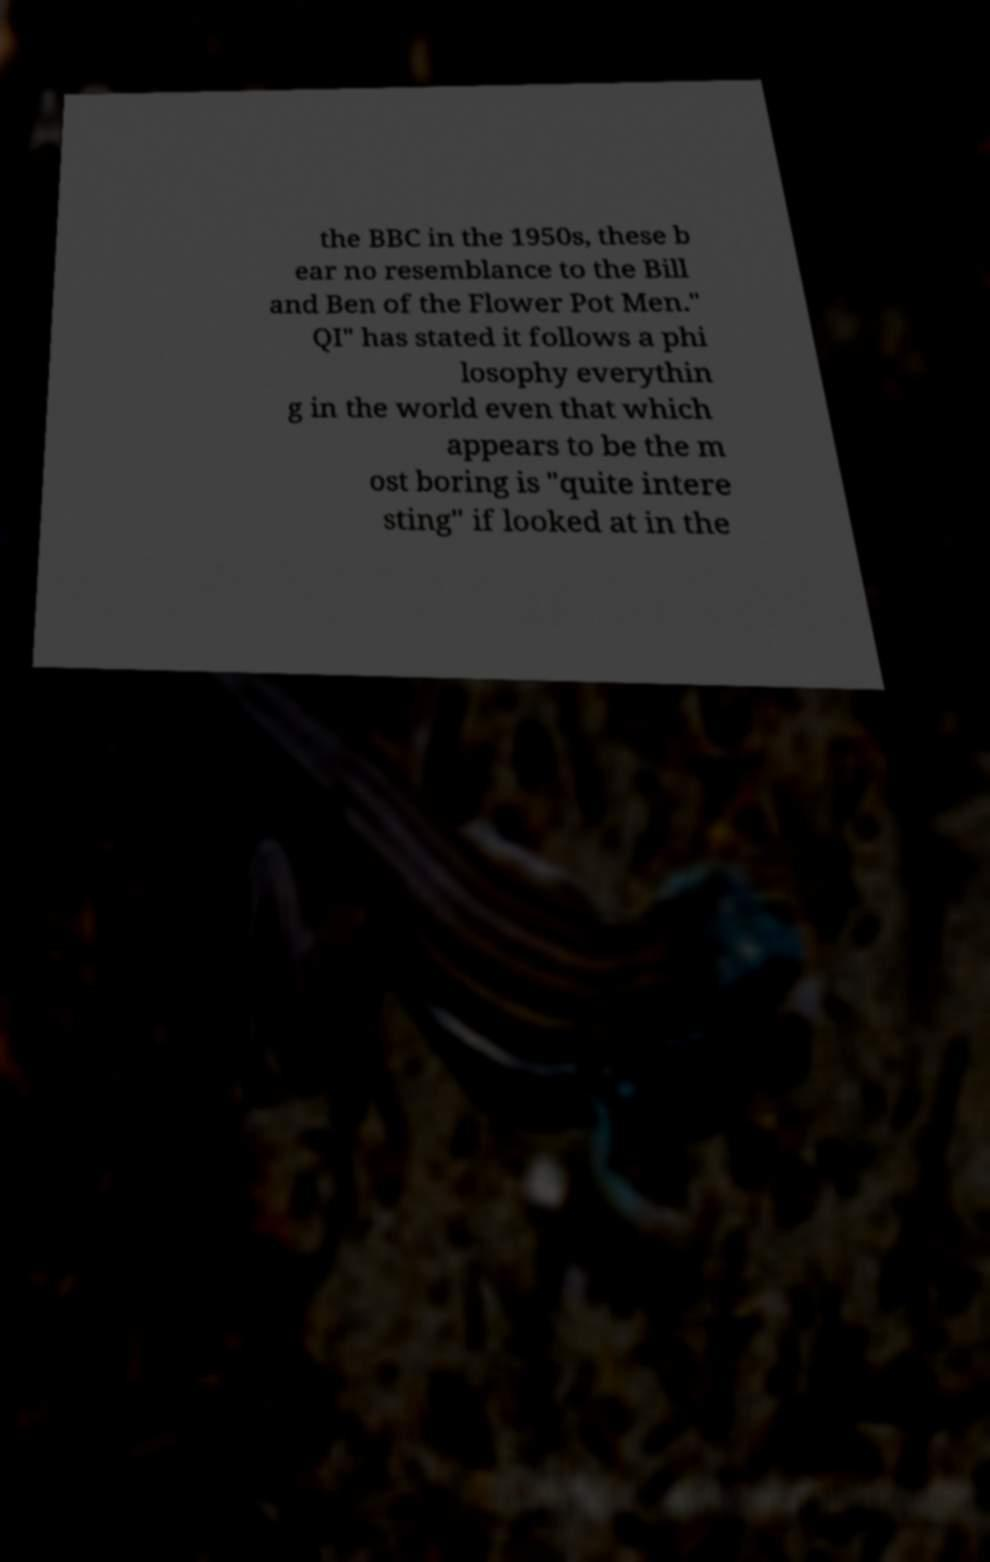I need the written content from this picture converted into text. Can you do that? the BBC in the 1950s, these b ear no resemblance to the Bill and Ben of the Flower Pot Men." QI" has stated it follows a phi losophy everythin g in the world even that which appears to be the m ost boring is "quite intere sting" if looked at in the 